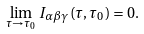<formula> <loc_0><loc_0><loc_500><loc_500>\lim _ { \tau \rightarrow \tau _ { 0 } } I _ { \alpha \beta \gamma } \left ( \tau , \tau _ { 0 } \right ) = 0 .</formula> 